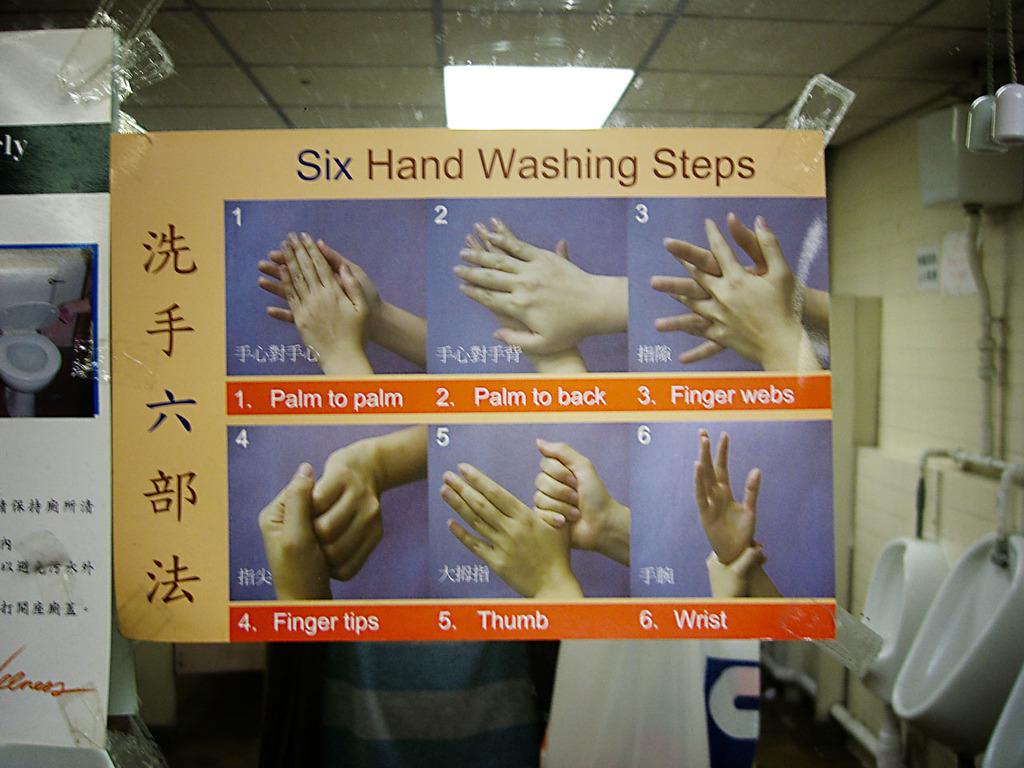How many steps for hand washing?
Offer a terse response. 6. 